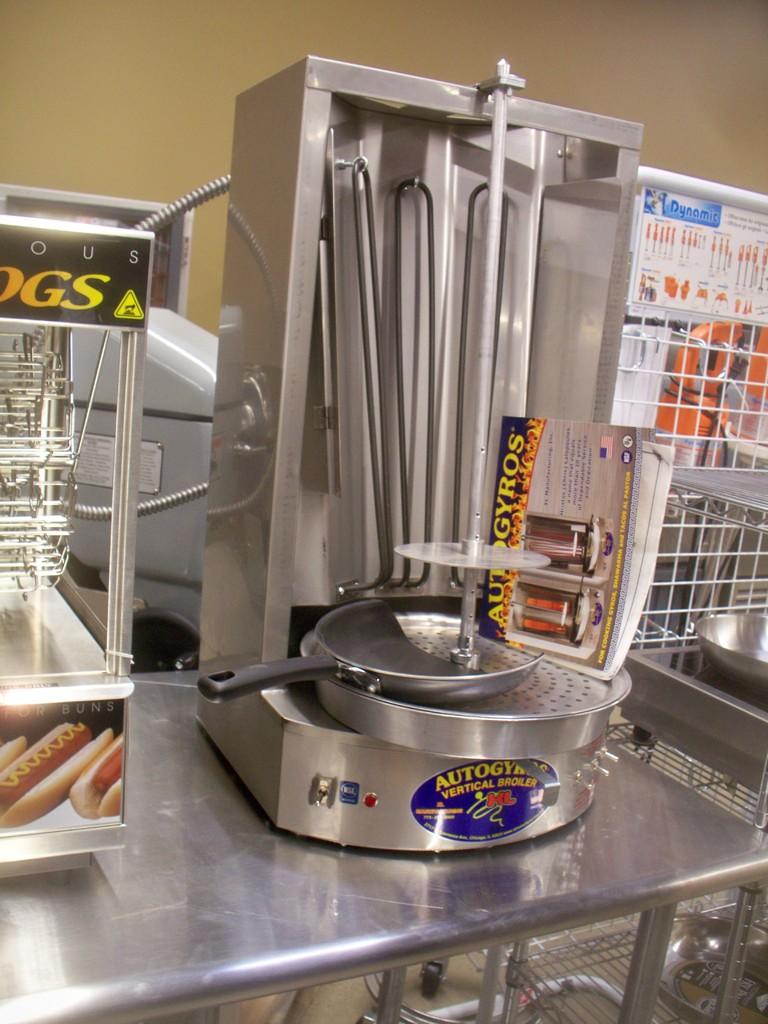What does the blue sign say in the right corner?
Offer a very short reply. Dynamic. Does that sign on the left say "hotdog buns?"?
Offer a very short reply. No. 